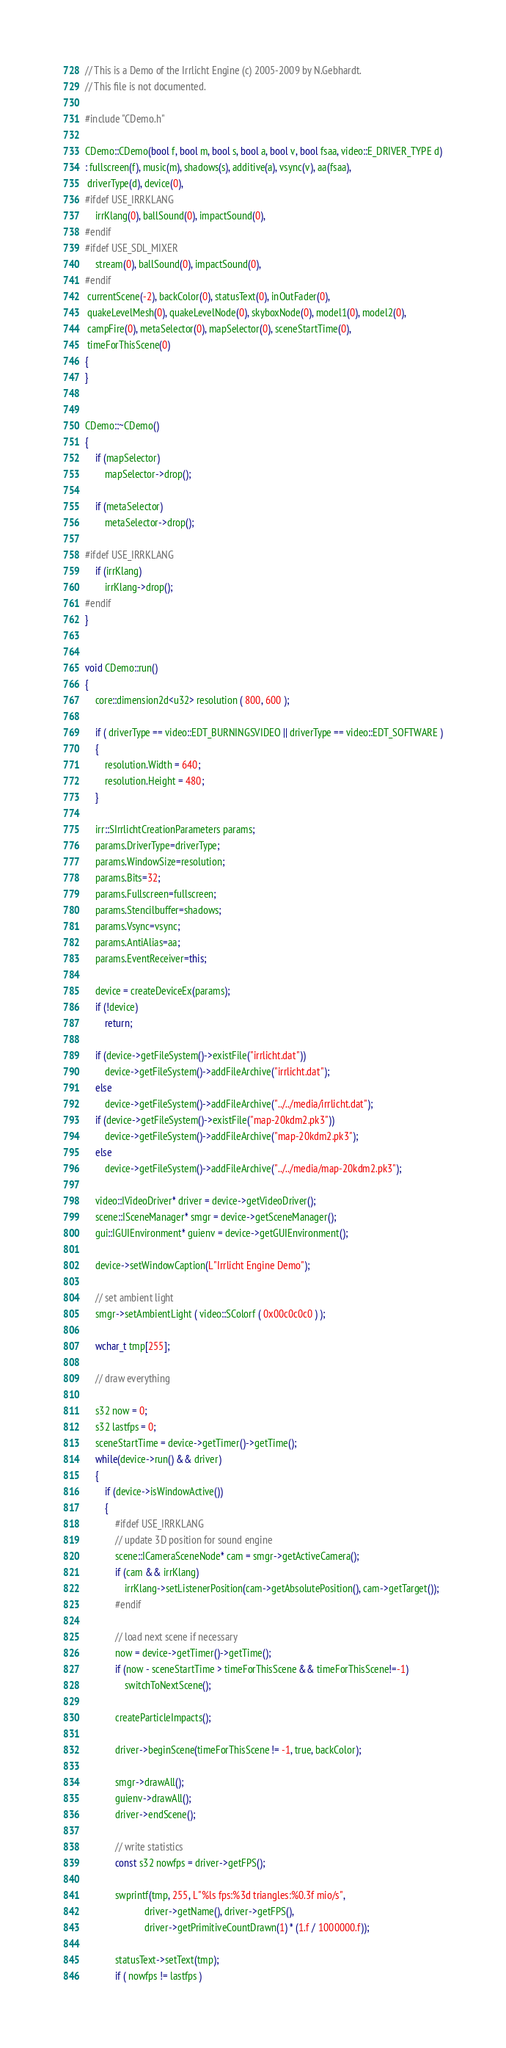<code> <loc_0><loc_0><loc_500><loc_500><_C++_>// This is a Demo of the Irrlicht Engine (c) 2005-2009 by N.Gebhardt.
// This file is not documented.

#include "CDemo.h"

CDemo::CDemo(bool f, bool m, bool s, bool a, bool v, bool fsaa, video::E_DRIVER_TYPE d)
: fullscreen(f), music(m), shadows(s), additive(a), vsync(v), aa(fsaa),
 driverType(d), device(0),
#ifdef USE_IRRKLANG
	irrKlang(0), ballSound(0), impactSound(0),
#endif
#ifdef USE_SDL_MIXER
	stream(0), ballSound(0), impactSound(0),
#endif
 currentScene(-2), backColor(0), statusText(0), inOutFader(0),
 quakeLevelMesh(0), quakeLevelNode(0), skyboxNode(0), model1(0), model2(0),
 campFire(0), metaSelector(0), mapSelector(0), sceneStartTime(0),
 timeForThisScene(0)
{
}


CDemo::~CDemo()
{
	if (mapSelector)
		mapSelector->drop();

	if (metaSelector)
		metaSelector->drop();

#ifdef USE_IRRKLANG
	if (irrKlang)
		irrKlang->drop();
#endif
}


void CDemo::run()
{
	core::dimension2d<u32> resolution ( 800, 600 );

	if ( driverType == video::EDT_BURNINGSVIDEO || driverType == video::EDT_SOFTWARE )
	{
		resolution.Width = 640;
		resolution.Height = 480;
	}

	irr::SIrrlichtCreationParameters params;
	params.DriverType=driverType;
	params.WindowSize=resolution;
	params.Bits=32;
	params.Fullscreen=fullscreen;
	params.Stencilbuffer=shadows;
	params.Vsync=vsync;
	params.AntiAlias=aa;
	params.EventReceiver=this;

	device = createDeviceEx(params);
	if (!device)
		return;

	if (device->getFileSystem()->existFile("irrlicht.dat"))
		device->getFileSystem()->addFileArchive("irrlicht.dat");
	else
		device->getFileSystem()->addFileArchive("../../media/irrlicht.dat");
	if (device->getFileSystem()->existFile("map-20kdm2.pk3"))
		device->getFileSystem()->addFileArchive("map-20kdm2.pk3");
	else
		device->getFileSystem()->addFileArchive("../../media/map-20kdm2.pk3");

	video::IVideoDriver* driver = device->getVideoDriver();
	scene::ISceneManager* smgr = device->getSceneManager();
	gui::IGUIEnvironment* guienv = device->getGUIEnvironment();

	device->setWindowCaption(L"Irrlicht Engine Demo");

	// set ambient light
	smgr->setAmbientLight ( video::SColorf ( 0x00c0c0c0 ) );

	wchar_t tmp[255];

	// draw everything

	s32 now = 0;
	s32 lastfps = 0;
	sceneStartTime = device->getTimer()->getTime();
	while(device->run() && driver)
	{
		if (device->isWindowActive())
		{
			#ifdef USE_IRRKLANG
			// update 3D position for sound engine
			scene::ICameraSceneNode* cam = smgr->getActiveCamera();
			if (cam && irrKlang)
				irrKlang->setListenerPosition(cam->getAbsolutePosition(), cam->getTarget());
			#endif

			// load next scene if necessary
			now = device->getTimer()->getTime();
			if (now - sceneStartTime > timeForThisScene && timeForThisScene!=-1)
				switchToNextScene();

			createParticleImpacts();

			driver->beginScene(timeForThisScene != -1, true, backColor);

			smgr->drawAll();
			guienv->drawAll();
			driver->endScene();

			// write statistics
			const s32 nowfps = driver->getFPS();

			swprintf(tmp, 255, L"%ls fps:%3d triangles:%0.3f mio/s",
						driver->getName(), driver->getFPS(),
						driver->getPrimitiveCountDrawn(1) * (1.f / 1000000.f));

			statusText->setText(tmp);
			if ( nowfps != lastfps )</code> 